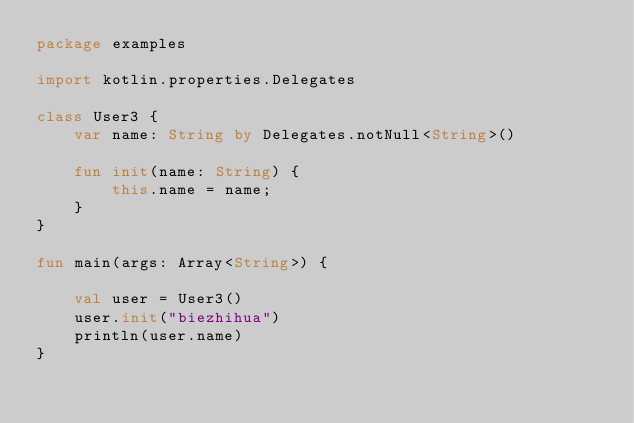Convert code to text. <code><loc_0><loc_0><loc_500><loc_500><_Kotlin_>package examples

import kotlin.properties.Delegates

class User3 {
    var name: String by Delegates.notNull<String>()

    fun init(name: String) {
        this.name = name;
    }
}

fun main(args: Array<String>) {

    val user = User3()
    user.init("biezhihua")
    println(user.name)
}</code> 